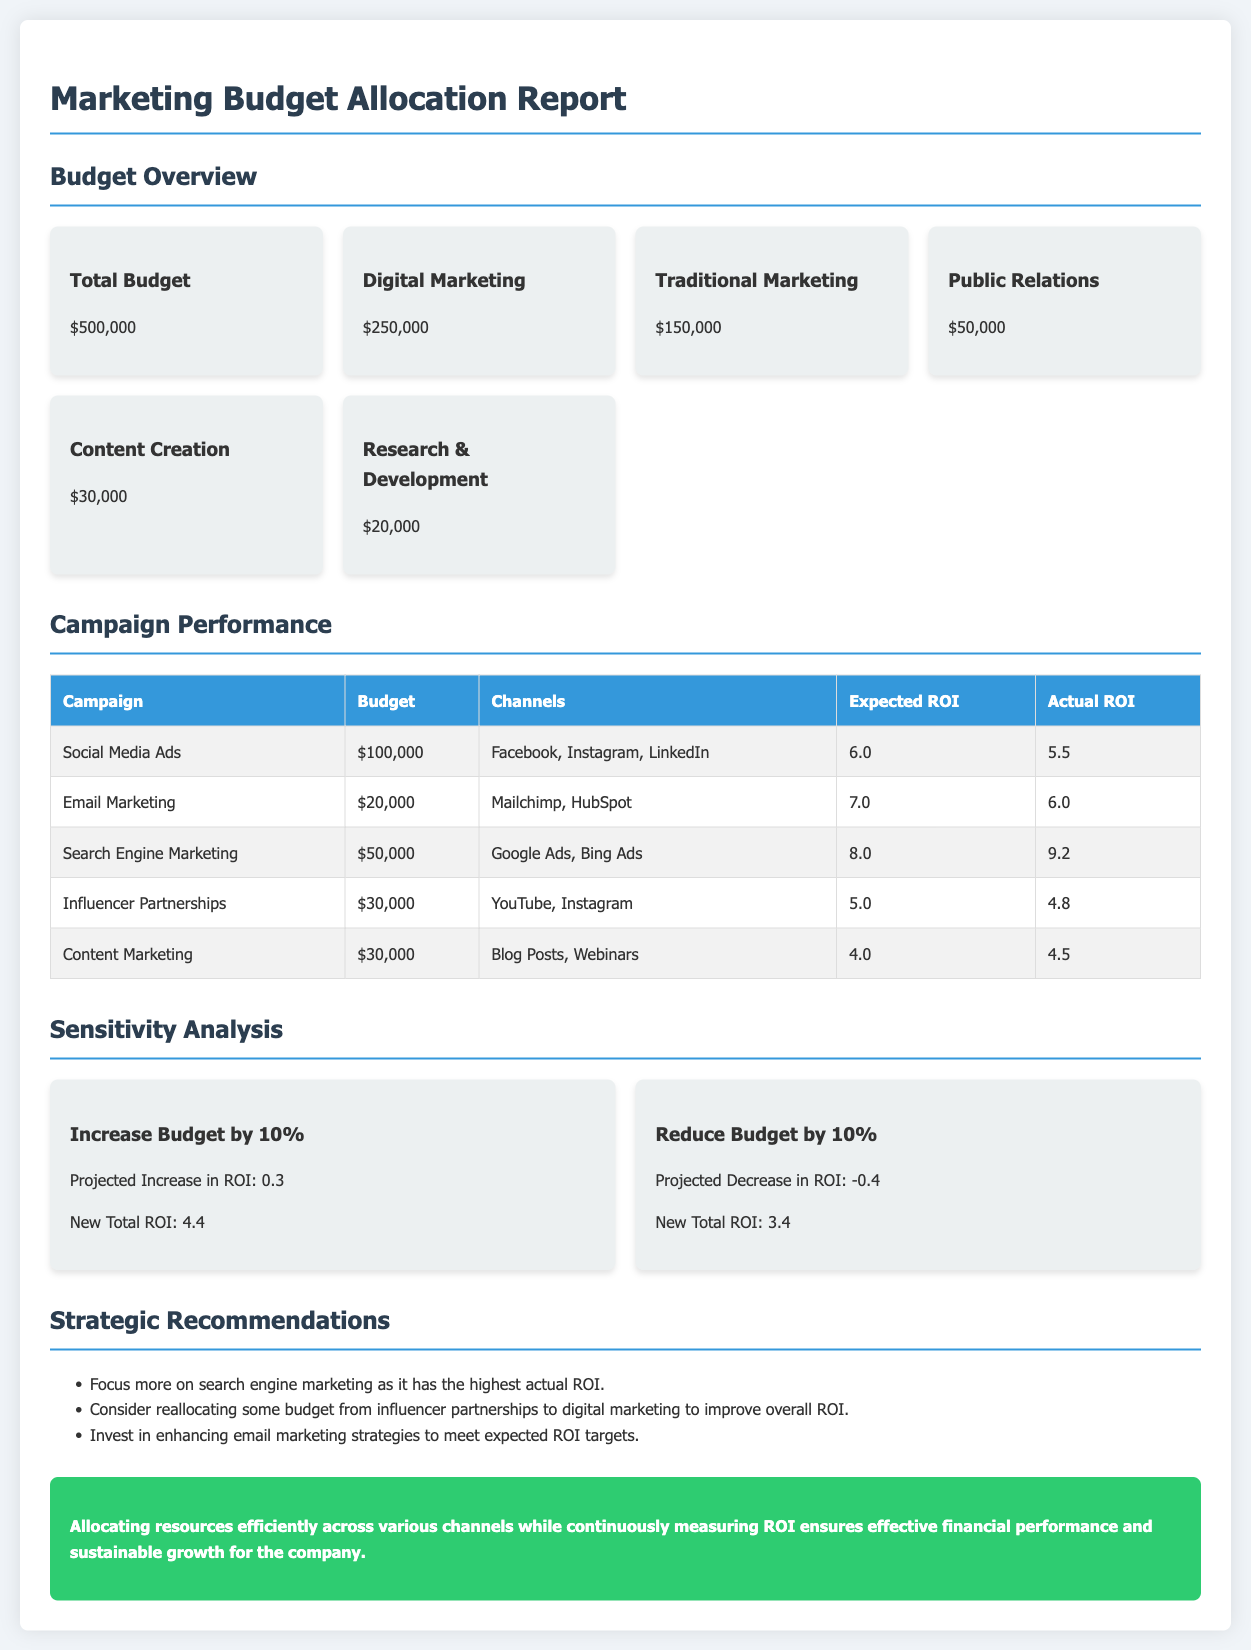What is the total budget? The total budget is explicitly mentioned in the document as $500,000.
Answer: $500,000 What is the budget allocated for digital marketing? The budget for digital marketing is directly stated as $250,000 in the budget overview section.
Answer: $250,000 Which campaign has the highest expected ROI? Upon reviewing the campaign performance table, Search Engine Marketing has the highest expected ROI of 8.0.
Answer: 8.0 What is the actual ROI for Email Marketing? The actual ROI for Email Marketing is listed in the campaign performance table as 6.0.
Answer: 6.0 What was the budget for influencer partnerships? The budget allocated for influencer partnerships is clearly stated in the campaign performance table as $30,000.
Answer: $30,000 What is the projected increase in ROI if the budget is increased by 10%? The sensitivity analysis section shows a projected increase in ROI of 0.3 if the budget is increased by 10%.
Answer: 0.3 Which marketing strategy is recommended to enhance ROI? The strategic recommendations suggest focusing more on search engine marketing to improve ROI.
Answer: Search engine marketing What is the combined budget for traditional marketing and public relations? The combined budget of the two is calculated as $150,000 (traditional marketing) + $50,000 (public relations) = $200,000.
Answer: $200,000 What is the conclusion of the report? The conclusion summarizing the report emphasizes efficient resource allocation and measuring ROI for sustainable growth.
Answer: Allocating resources efficiently across various channels ensures effective financial performance 